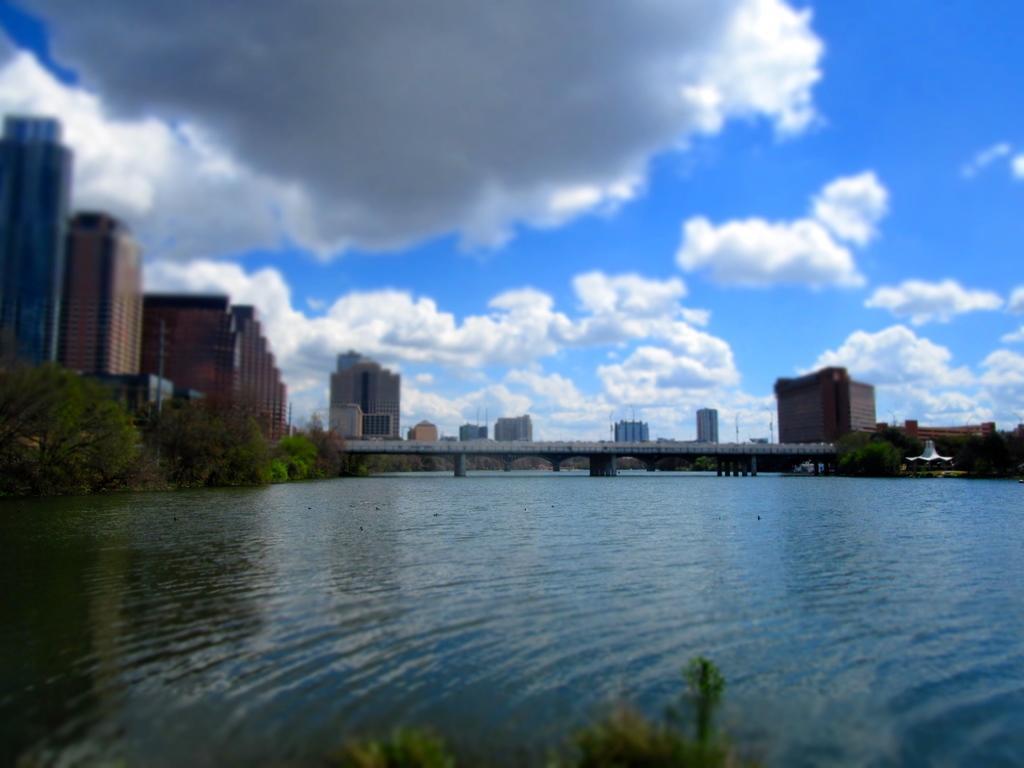Describe this image in one or two sentences. This is an outside view. At the bottom there is a river. In the background there is a bridge. On the right and left sides of the image I can see the trees. In the background there are many buildings. At the top of the image I can see the sky and clouds. 